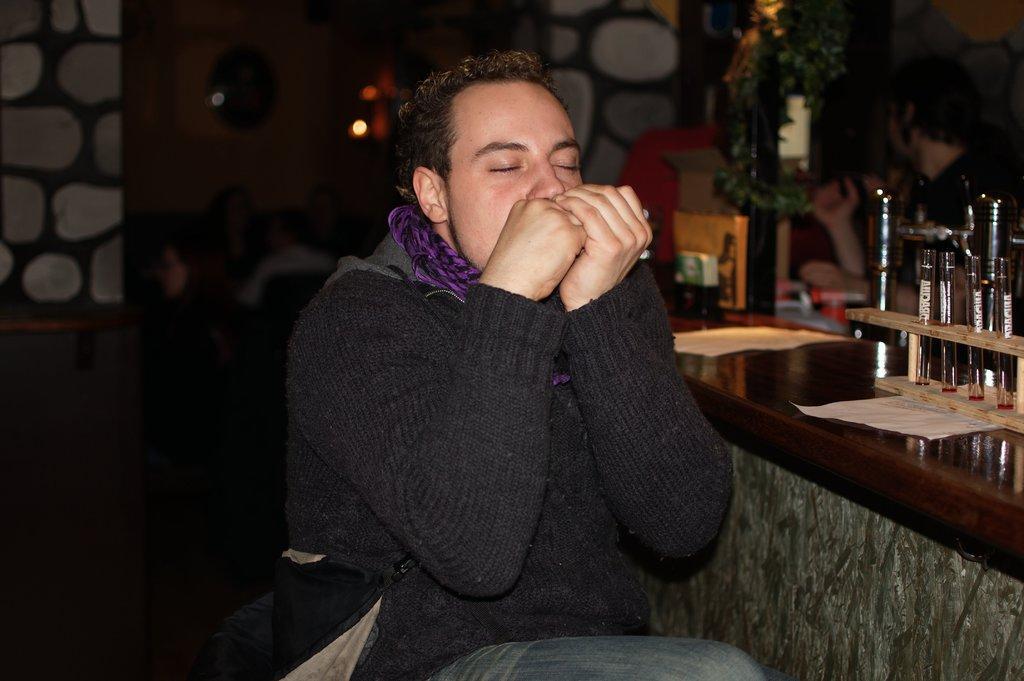In one or two sentences, can you explain what this image depicts? In the picture I can see a man is sitting. In the background I can see a table which has some objects on it. I can also see a wall and some other objects. 